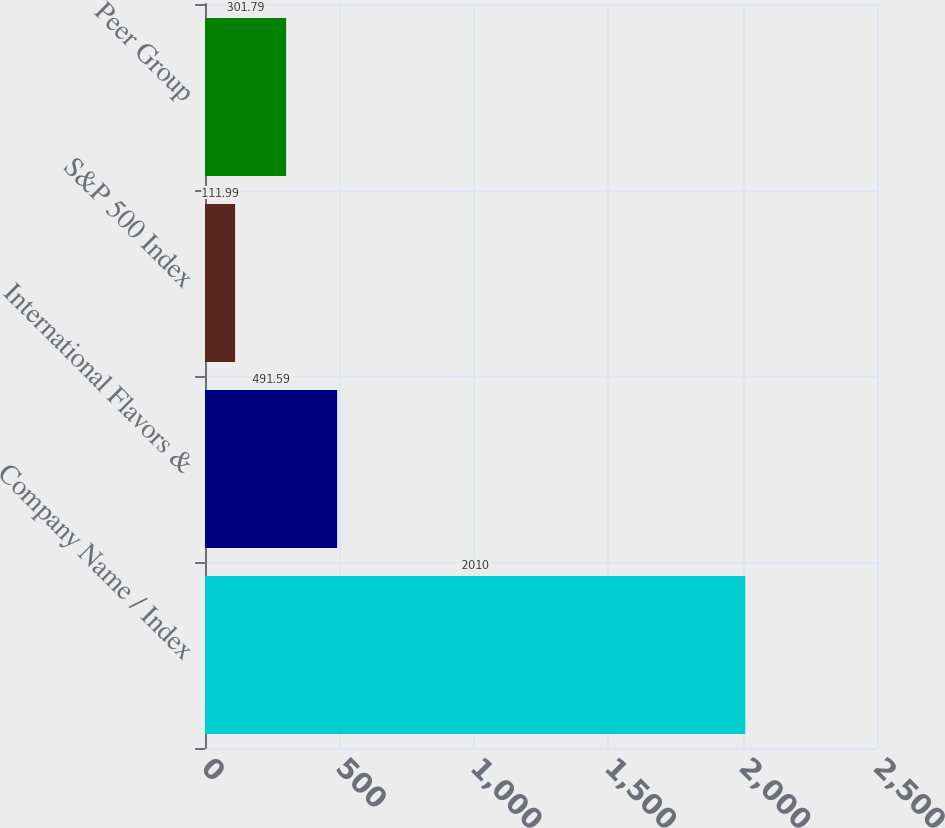Convert chart to OTSL. <chart><loc_0><loc_0><loc_500><loc_500><bar_chart><fcel>Company Name / Index<fcel>International Flavors &<fcel>S&P 500 Index<fcel>Peer Group<nl><fcel>2010<fcel>491.59<fcel>111.99<fcel>301.79<nl></chart> 